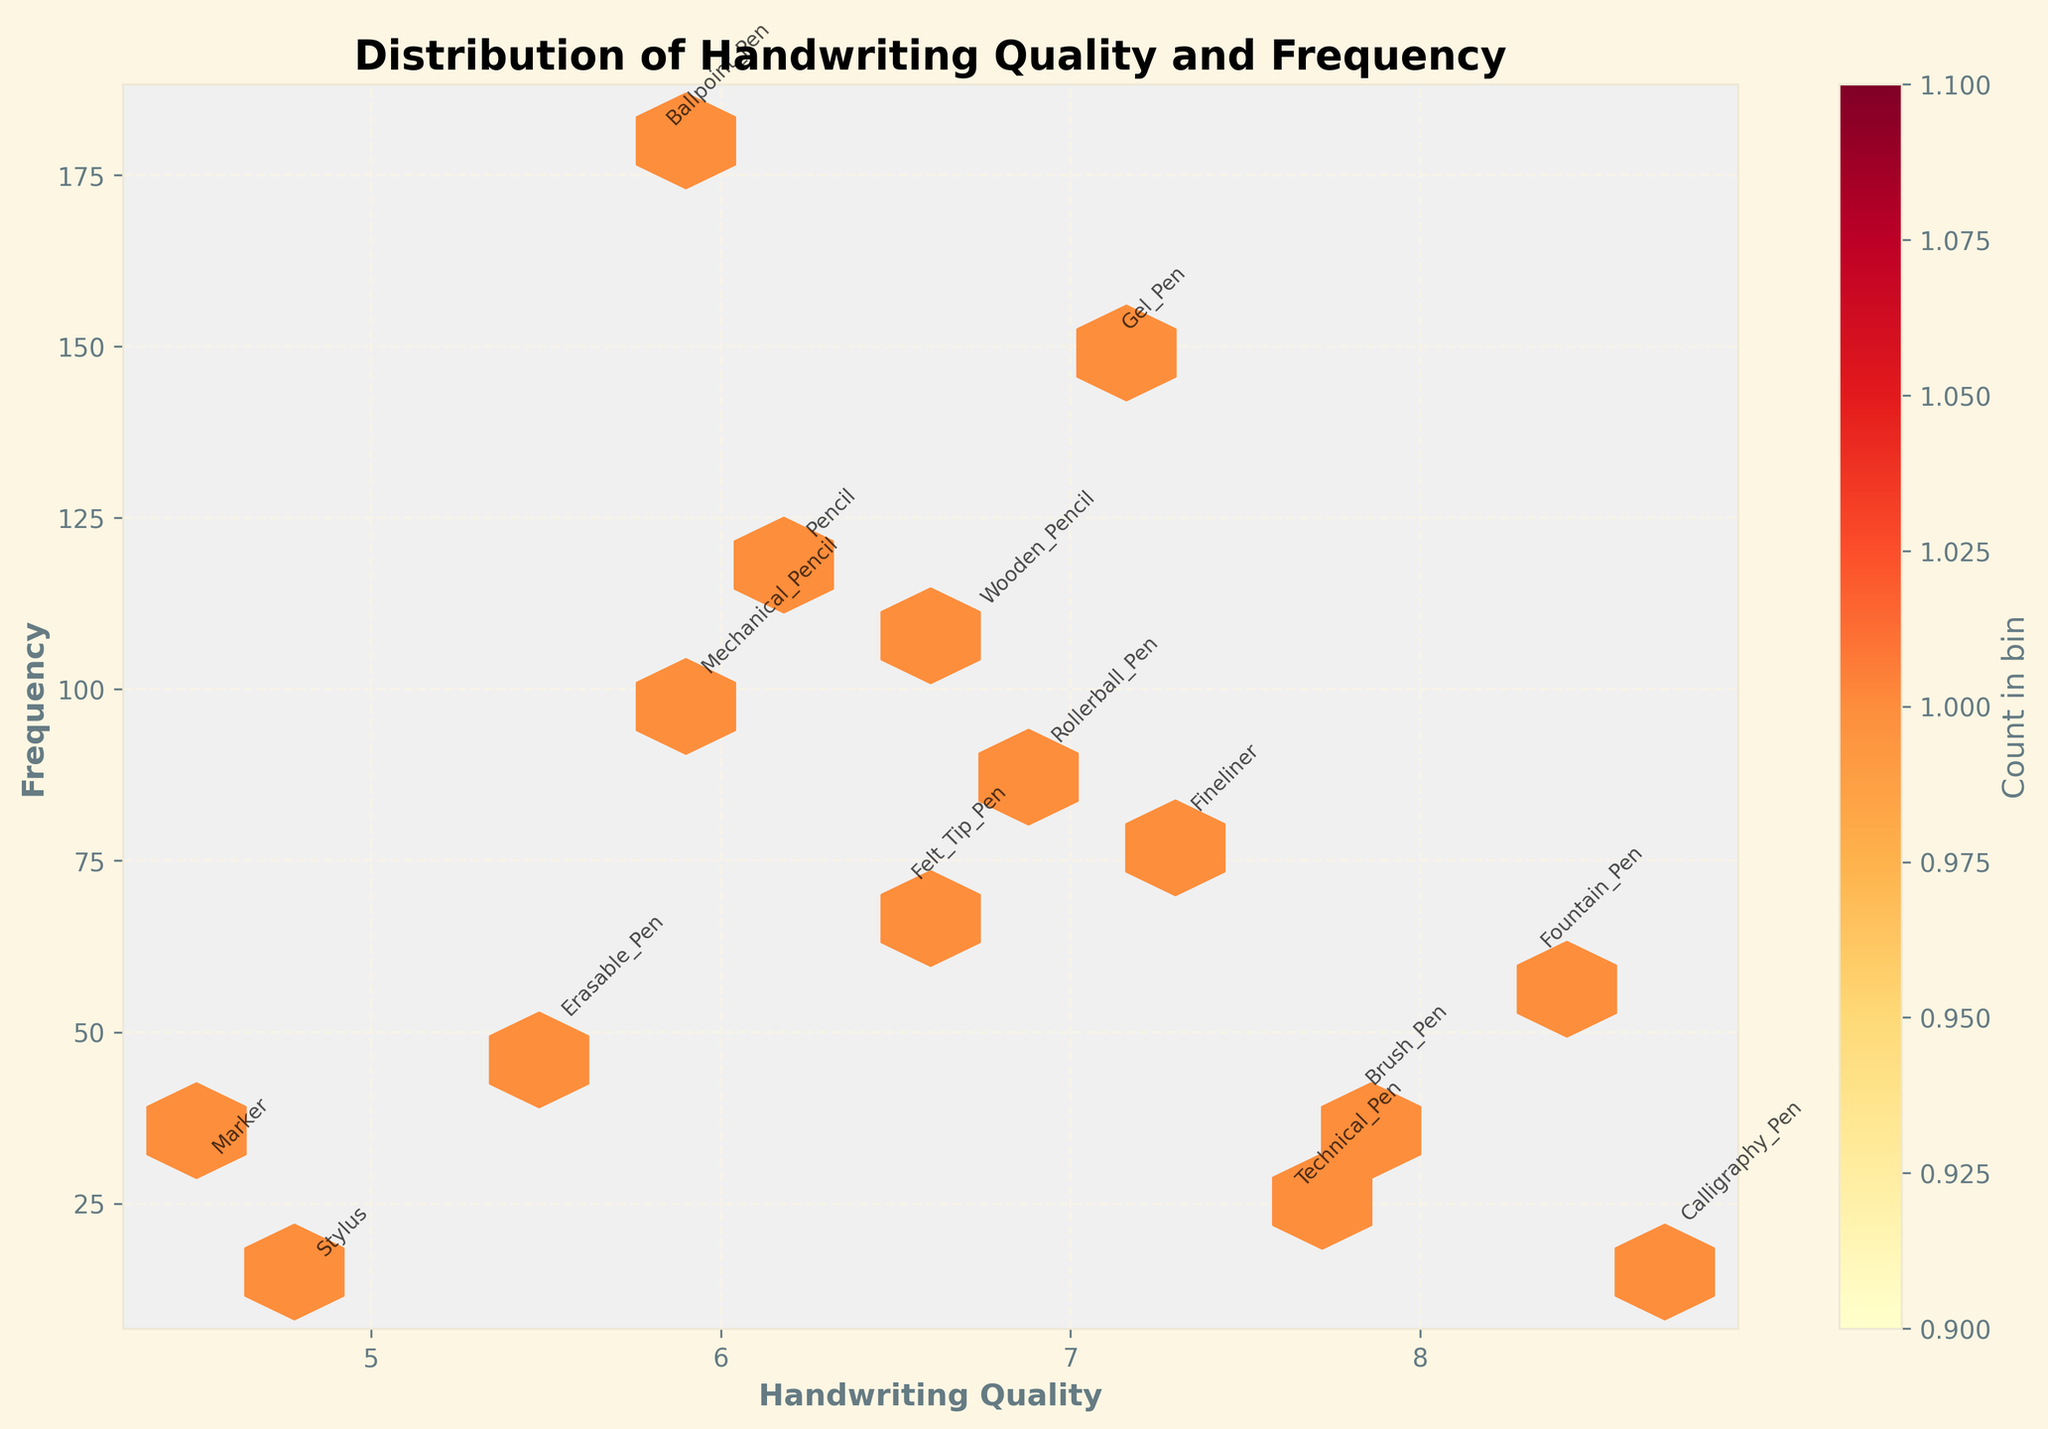What is the title of the hexbin plot? The title of the hexbin plot is displayed at the top of the figure in bold and large font.
Answer: Distribution of Handwriting Quality and Frequency What are the labels on the x-axis and y-axis? The labels on the axes are displayed along the bottom (x-axis) and left side (y-axis) of the plot, in bold font.
Answer: Handwriting Quality, Frequency Which writing instrument has the highest handwriting quality? Each writing instrument's name is annotated near its corresponding data point. By finding the point with the highest handwriting quality value on the x-axis, we can determine the answer.
Answer: Calligraphy Pen Which writing instrument has the lowest frequency? By locating the data point positioned lowest on the y-axis and reading the annotation, we can identify the instrument with the lowest frequency.
Answer: Stylus How many color bins are used in the hexbin plot? The hexbin plot uses colors to represent data density within hexagonal bins. By counting the distinct color gradations in the plot, we determine the number of color bins.
Answer: 15 Which writing instrument shows a combination of relatively high handwriting quality and high frequency? We look for a data point that falls in the upper right section of the plot, where both handwriting quality (x-axis) and frequency (y-axis) are high.
Answer: Gel Pen Is there any writing instrument with both low handwriting quality and low frequency? Locate a data point in the lower left region of the plot, which indicates both low handwriting quality and low frequency, and read the annotation.
Answer: Stylus Compare the handwriting quality between Gel Pen and Rollerball Pen. Which has better handwriting quality? Find the data points for both Gel Pen and Rollerball Pen and compare their positions along the x-axis.
Answer: Gel Pen Among the instruments, which has the closest handwriting quality score to 7? Find the data point closest to the value of 7 on the x-axis and read the annotation corresponding to that point.
Answer: Fineliner What can you infer about the popularity of high-quality handwriting instruments based on the frequency data? Observe the distribution of frequency along the y-axis for instruments with high handwriting quality (closer to the right on the x-axis). Fewer data points here suggest that instruments yielding the highest handwriting quality are less frequently used.
Answer: High-quality instruments like Calligraphy Pen and Fountain Pen have lower frequencies 